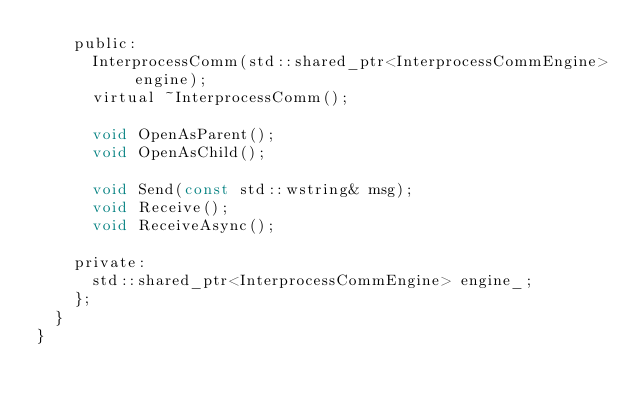Convert code to text. <code><loc_0><loc_0><loc_500><loc_500><_C_>		public:
			InterprocessComm(std::shared_ptr<InterprocessCommEngine> engine);
			virtual ~InterprocessComm();

			void OpenAsParent();
			void OpenAsChild();

			void Send(const std::wstring& msg);
			void Receive();
			void ReceiveAsync();

		private:
			std::shared_ptr<InterprocessCommEngine> engine_;
		};
	}
}
</code> 